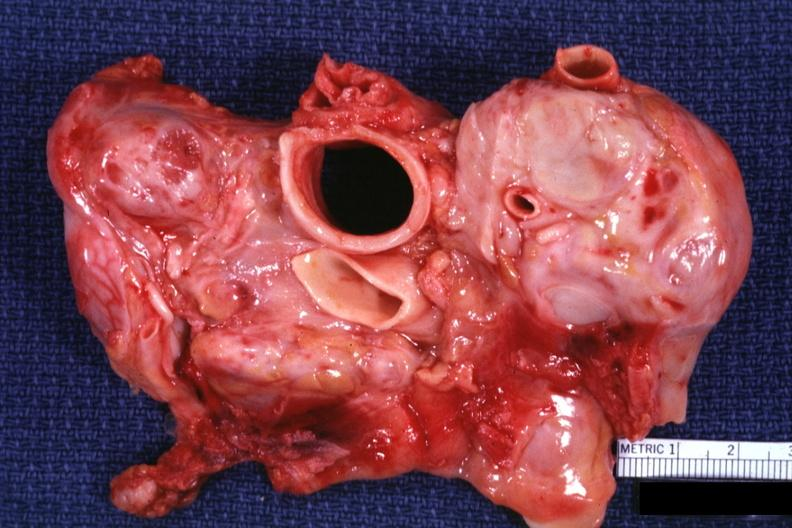what is present?
Answer the question using a single word or phrase. Metastatic carcinoma 